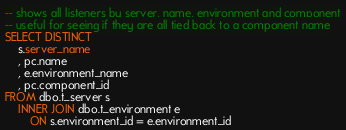Convert code to text. <code><loc_0><loc_0><loc_500><loc_500><_SQL_>-- shows all listeners by server, name, environment and component
-- useful for seeing if they are all tied back to a component name
SELECT DISTINCT
    s.server_name
    , pc.name
    , e.environment_name
    , pc.component_id
FROM dbo.t_server s
    INNER JOIN dbo.t_environment e
        ON s.environment_id = e.environment_id</code> 